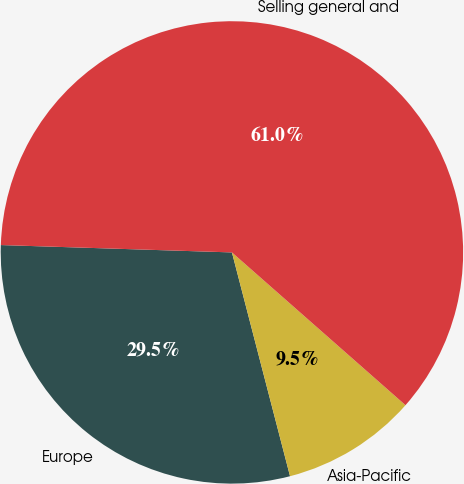Convert chart to OTSL. <chart><loc_0><loc_0><loc_500><loc_500><pie_chart><fcel>Europe<fcel>Asia-Pacific<fcel>Selling general and<nl><fcel>29.55%<fcel>9.47%<fcel>60.98%<nl></chart> 